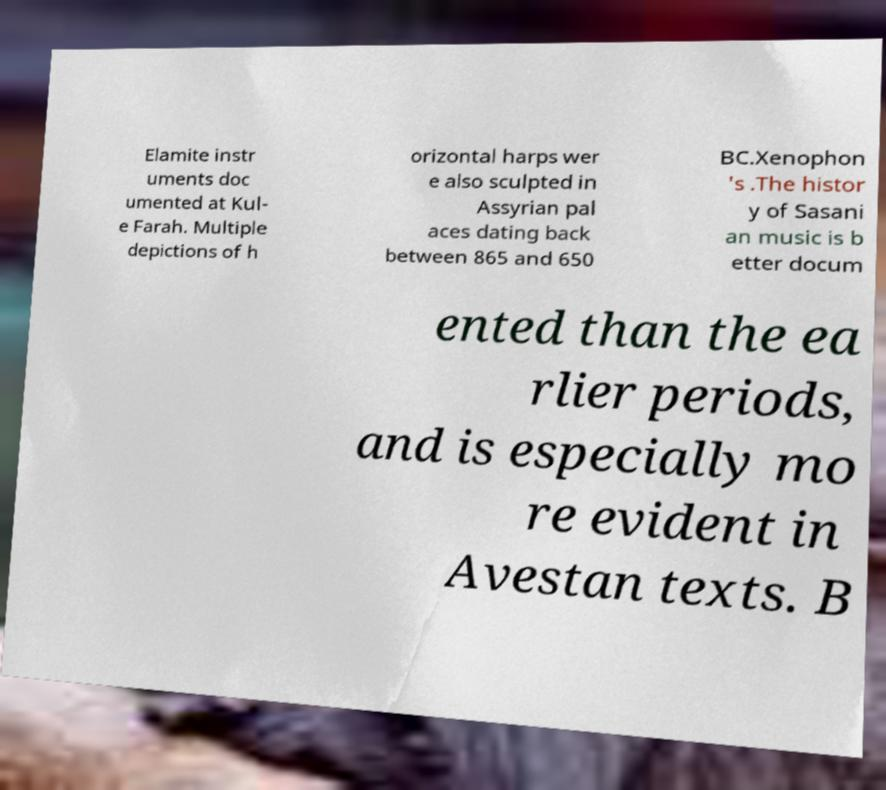There's text embedded in this image that I need extracted. Can you transcribe it verbatim? Elamite instr uments doc umented at Kul- e Farah. Multiple depictions of h orizontal harps wer e also sculpted in Assyrian pal aces dating back between 865 and 650 BC.Xenophon 's .The histor y of Sasani an music is b etter docum ented than the ea rlier periods, and is especially mo re evident in Avestan texts. B 